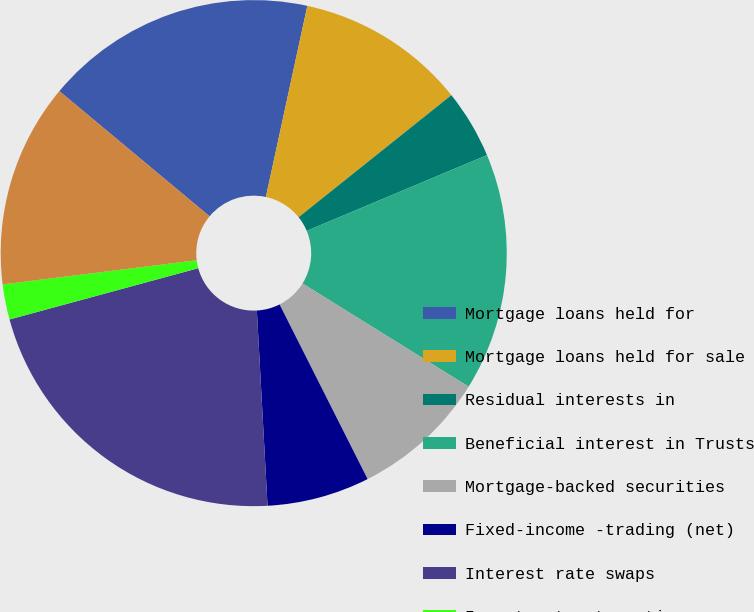Convert chart. <chart><loc_0><loc_0><loc_500><loc_500><pie_chart><fcel>Mortgage loans held for<fcel>Mortgage loans held for sale<fcel>Residual interests in<fcel>Beneficial interest in Trusts<fcel>Mortgage-backed securities<fcel>Fixed-income -trading (net)<fcel>Interest rate swaps<fcel>Investments at captive<fcel>Put options on Eurodollar<nl><fcel>17.34%<fcel>10.87%<fcel>4.4%<fcel>15.18%<fcel>8.72%<fcel>6.56%<fcel>21.65%<fcel>2.25%<fcel>13.03%<nl></chart> 